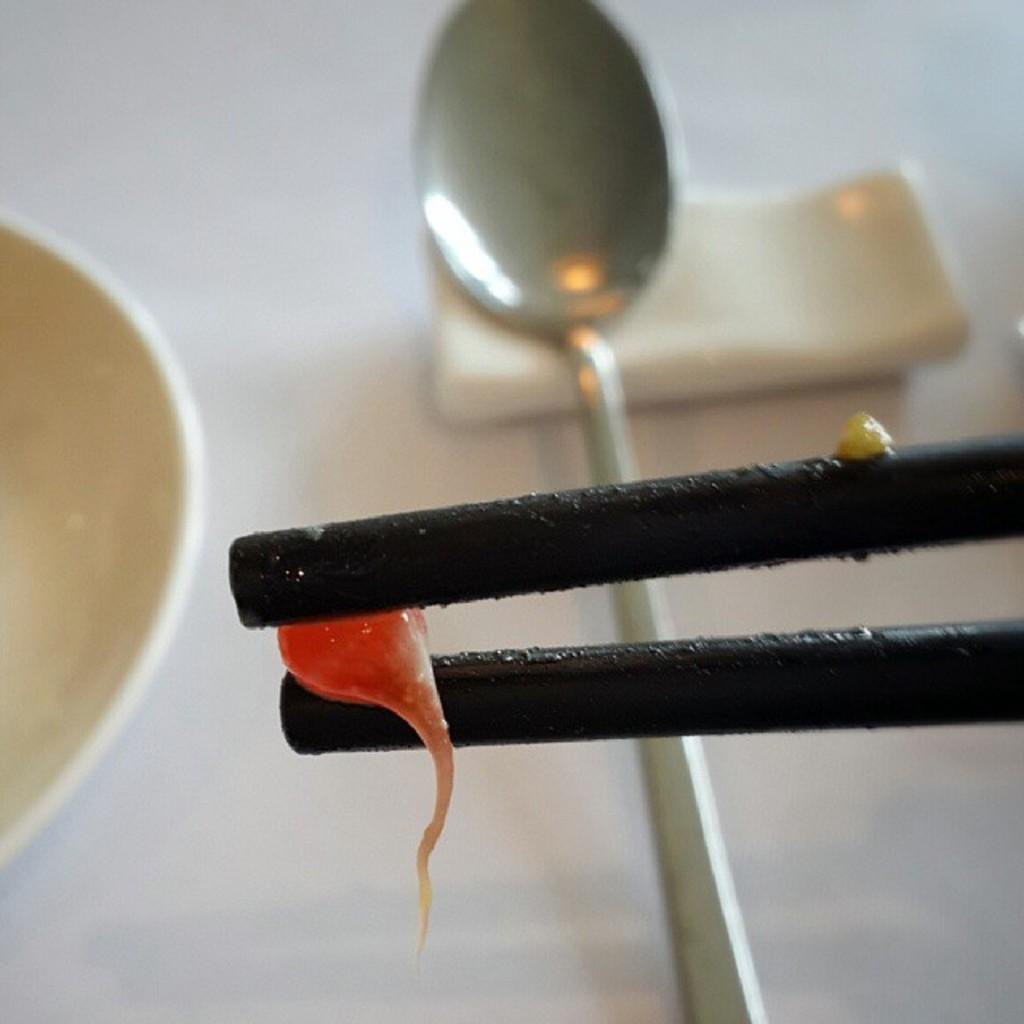What is in the bowl that is visible in the image? There is a red color liquid bubble in the image. What utensils are visible in the image? There is a spoon and chopsticks in the image. What might be used for cleaning or wiping in the image? Tissue papers are present in the image for cleaning or wiping. What type of wheel can be seen in the image? There is no wheel present in the image. What list is being referred to in the image? There is no list mentioned or depicted in the image. 